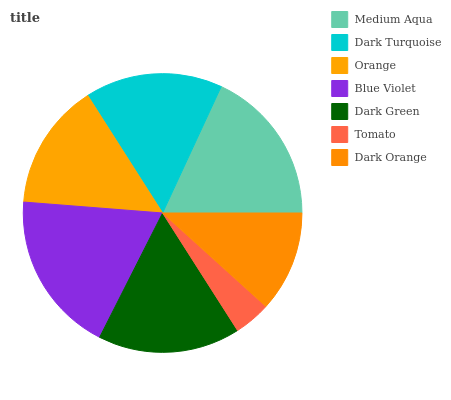Is Tomato the minimum?
Answer yes or no. Yes. Is Blue Violet the maximum?
Answer yes or no. Yes. Is Dark Turquoise the minimum?
Answer yes or no. No. Is Dark Turquoise the maximum?
Answer yes or no. No. Is Medium Aqua greater than Dark Turquoise?
Answer yes or no. Yes. Is Dark Turquoise less than Medium Aqua?
Answer yes or no. Yes. Is Dark Turquoise greater than Medium Aqua?
Answer yes or no. No. Is Medium Aqua less than Dark Turquoise?
Answer yes or no. No. Is Dark Turquoise the high median?
Answer yes or no. Yes. Is Dark Turquoise the low median?
Answer yes or no. Yes. Is Dark Green the high median?
Answer yes or no. No. Is Medium Aqua the low median?
Answer yes or no. No. 